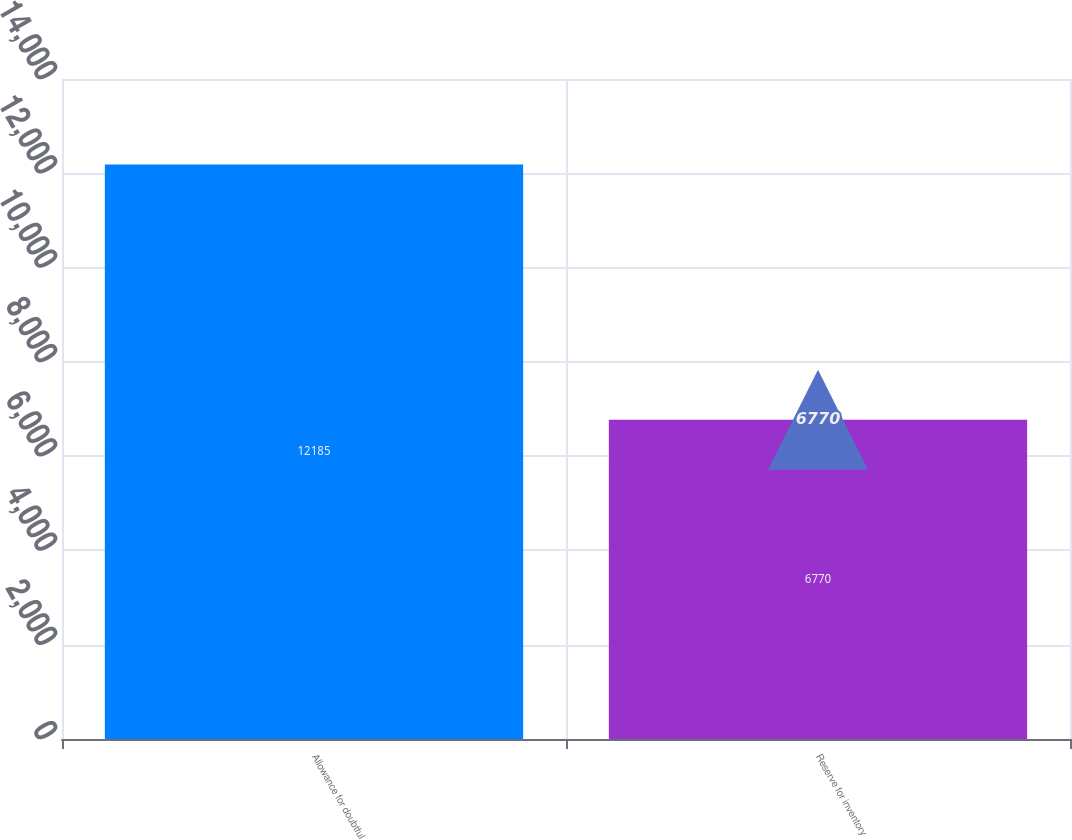Convert chart. <chart><loc_0><loc_0><loc_500><loc_500><bar_chart><fcel>Allowance for doubtful<fcel>Reserve for inventory<nl><fcel>12185<fcel>6770<nl></chart> 